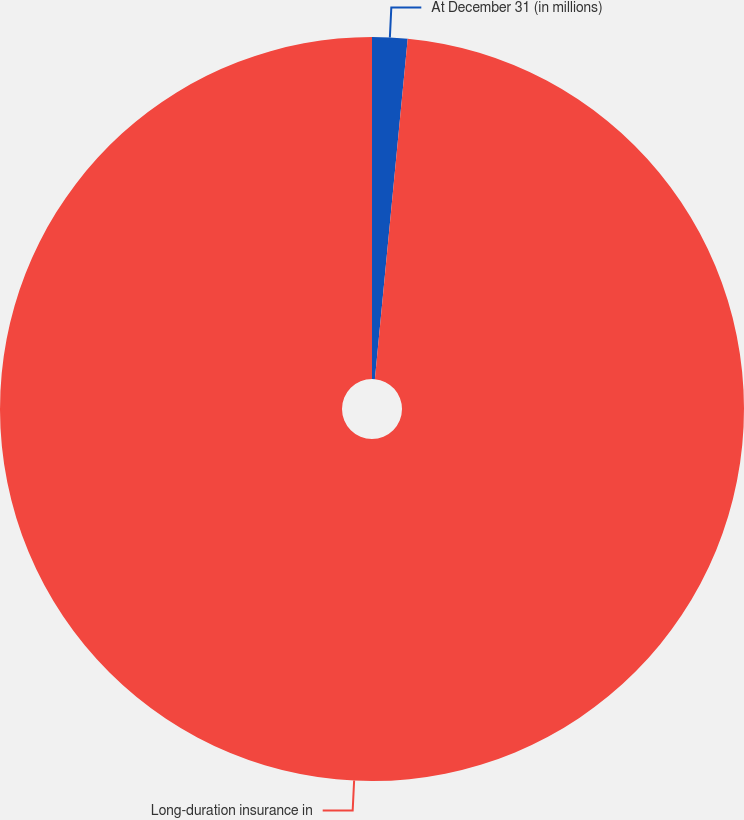Convert chart. <chart><loc_0><loc_0><loc_500><loc_500><pie_chart><fcel>At December 31 (in millions)<fcel>Long-duration insurance in<nl><fcel>1.53%<fcel>98.47%<nl></chart> 